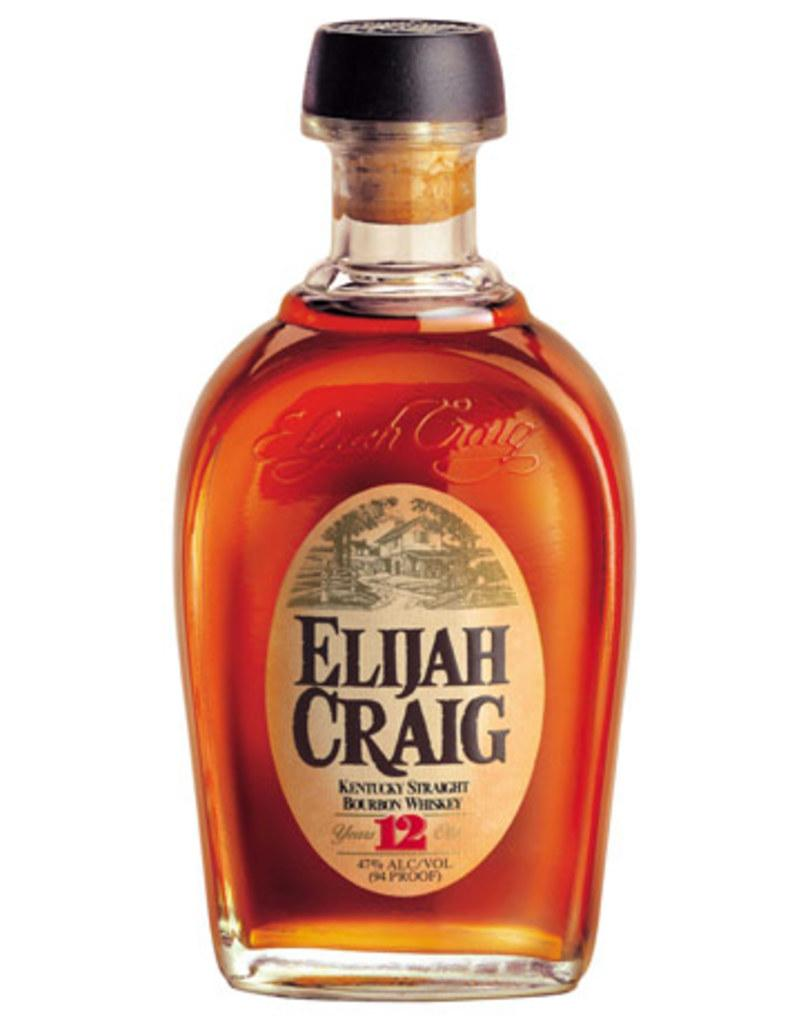<image>
Summarize the visual content of the image. A simple image of a bottle of Elijah Craig whisky against a white background. 